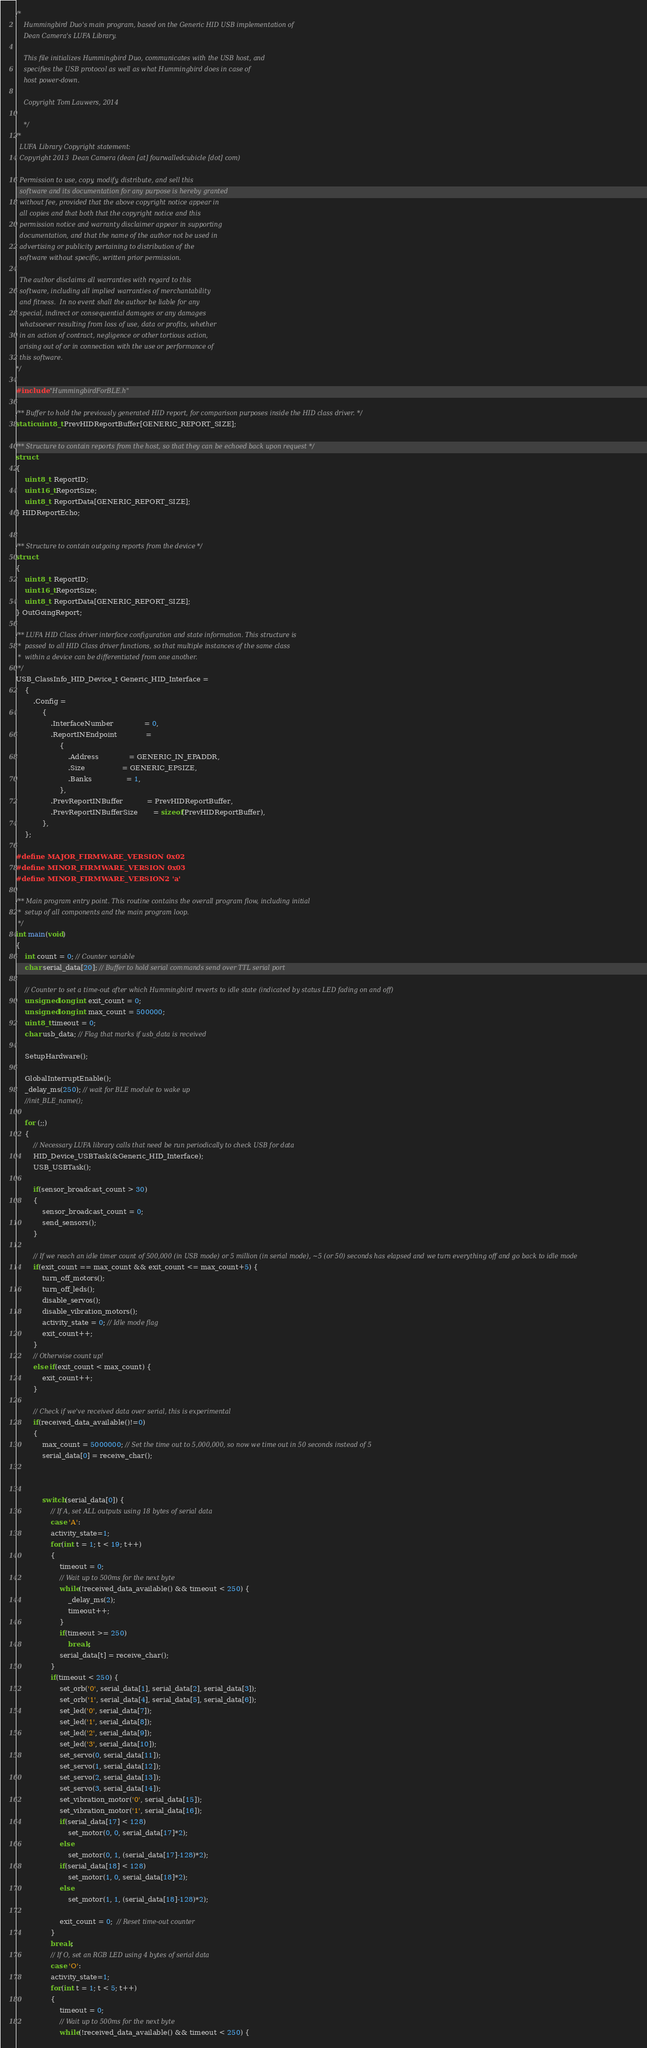<code> <loc_0><loc_0><loc_500><loc_500><_C_>/*
	Hummingbird Duo's main program, based on the Generic HID USB implementation of
	Dean Camera's LUFA Library.

	This file initializes Hummingbird Duo, communicates with the USB host, and
	specifies the USB protocol as well as what Hummingbird does in case of
	host power-down.

	Copyright Tom Lauwers, 2014

	*/
/*
  LUFA Library Copyright statement:
  Copyright 2013  Dean Camera (dean [at] fourwalledcubicle [dot] com)

  Permission to use, copy, modify, distribute, and sell this
  software and its documentation for any purpose is hereby granted
  without fee, provided that the above copyright notice appear in
  all copies and that both that the copyright notice and this
  permission notice and warranty disclaimer appear in supporting
  documentation, and that the name of the author not be used in
  advertising or publicity pertaining to distribution of the
  software without specific, written prior permission.

  The author disclaims all warranties with regard to this
  software, including all implied warranties of merchantability
  and fitness.  In no event shall the author be liable for any
  special, indirect or consequential damages or any damages
  whatsoever resulting from loss of use, data or profits, whether
  in an action of contract, negligence or other tortious action,
  arising out of or in connection with the use or performance of
  this software.
*/

#include "HummingbirdForBLE.h"

/** Buffer to hold the previously generated HID report, for comparison purposes inside the HID class driver. */
static uint8_t PrevHIDReportBuffer[GENERIC_REPORT_SIZE];

/** Structure to contain reports from the host, so that they can be echoed back upon request */
struct
{
	uint8_t  ReportID;
	uint16_t ReportSize;
	uint8_t  ReportData[GENERIC_REPORT_SIZE];
} HIDReportEcho;


/** Structure to contain outgoing reports from the device */
struct
{
	uint8_t  ReportID;
	uint16_t ReportSize;
	uint8_t  ReportData[GENERIC_REPORT_SIZE];
} OutGoingReport;

/** LUFA HID Class driver interface configuration and state information. This structure is
 *  passed to all HID Class driver functions, so that multiple instances of the same class
 *  within a device can be differentiated from one another.
 */
USB_ClassInfo_HID_Device_t Generic_HID_Interface =
	{
		.Config =
			{
				.InterfaceNumber              = 0,
				.ReportINEndpoint             =
					{
						.Address              = GENERIC_IN_EPADDR,
						.Size                 = GENERIC_EPSIZE,
						.Banks                = 1,
					},
				.PrevReportINBuffer           = PrevHIDReportBuffer,
				.PrevReportINBufferSize       = sizeof(PrevHIDReportBuffer),
			},
	};

#define MAJOR_FIRMWARE_VERSION 0x02
#define MINOR_FIRMWARE_VERSION 0x03
#define MINOR_FIRMWARE_VERSION2 'a'

/** Main program entry point. This routine contains the overall program flow, including initial
 *  setup of all components and the main program loop.
 */
int main(void)
{
	int count = 0; // Counter variable
	char serial_data[20]; // Buffer to hold serial commands send over TTL serial port

	// Counter to set a time-out after which Hummingbird reverts to idle state (indicated by status LED fading on and off)
	unsigned long int exit_count = 0;
	unsigned long int max_count = 500000;
	uint8_t timeout = 0;
	char usb_data; // Flag that marks if usb_data is received

	SetupHardware();

	GlobalInterruptEnable();
	_delay_ms(250); // wait for BLE module to wake up
	//init_BLE_name();

	for (;;)
	{
		// Necessary LUFA library calls that need be run periodically to check USB for data
		HID_Device_USBTask(&Generic_HID_Interface);
		USB_USBTask();

		if(sensor_broadcast_count > 30)
		{
			sensor_broadcast_count = 0;
			send_sensors();
		}

		// If we reach an idle timer count of 500,000 (in USB mode) or 5 million (in serial mode), ~5 (or 50) seconds has elapsed and we turn everything off and go back to idle mode
		if(exit_count == max_count && exit_count <= max_count+5) {
			turn_off_motors();
			turn_off_leds();
			disable_servos();
			disable_vibration_motors();
			activity_state = 0; // Idle mode flag
			exit_count++;
		}
		// Otherwise count up!
		else if(exit_count < max_count) {
			exit_count++;
		}

		// Check if we've received data over serial, this is experimental
		if(received_data_available()!=0)
		{
			max_count = 5000000; // Set the time out to 5,000,000, so now we time out in 50 seconds instead of 5
			serial_data[0] = receive_char();
			
			
			
			switch(serial_data[0]) {
				// If A, set ALL outputs using 18 bytes of serial data
				case 'A':
				activity_state=1;
				for(int t = 1; t < 19; t++)
				{
					timeout = 0;
					// Wait up to 500ms for the next byte
					while(!received_data_available() && timeout < 250) {
						_delay_ms(2);
						timeout++;
					}
					if(timeout >= 250)
						break;
					serial_data[t] = receive_char();
				}
				if(timeout < 250) {
					set_orb('0', serial_data[1], serial_data[2], serial_data[3]);
					set_orb('1', serial_data[4], serial_data[5], serial_data[6]);
					set_led('0', serial_data[7]);
					set_led('1', serial_data[8]);
					set_led('2', serial_data[9]);
					set_led('3', serial_data[10]);
					set_servo(0, serial_data[11]);
					set_servo(1, serial_data[12]);
					set_servo(2, serial_data[13]);
					set_servo(3, serial_data[14]);
					set_vibration_motor('0', serial_data[15]);
					set_vibration_motor('1', serial_data[16]);
					if(serial_data[17] < 128)
						set_motor(0, 0, serial_data[17]*2);
					else
						set_motor(0, 1, (serial_data[17]-128)*2);
					if(serial_data[18] < 128)
						set_motor(1, 0, serial_data[18]*2);
					else
						set_motor(1, 1, (serial_data[18]-128)*2);
					
					exit_count = 0;  // Reset time-out counter
				}
				break;
				// If O, set an RGB LED using 4 bytes of serial data
				case 'O':
				activity_state=1;
				for(int t = 1; t < 5; t++)
				{
					timeout = 0;
					// Wait up to 500ms for the next byte
					while(!received_data_available() && timeout < 250) {</code> 